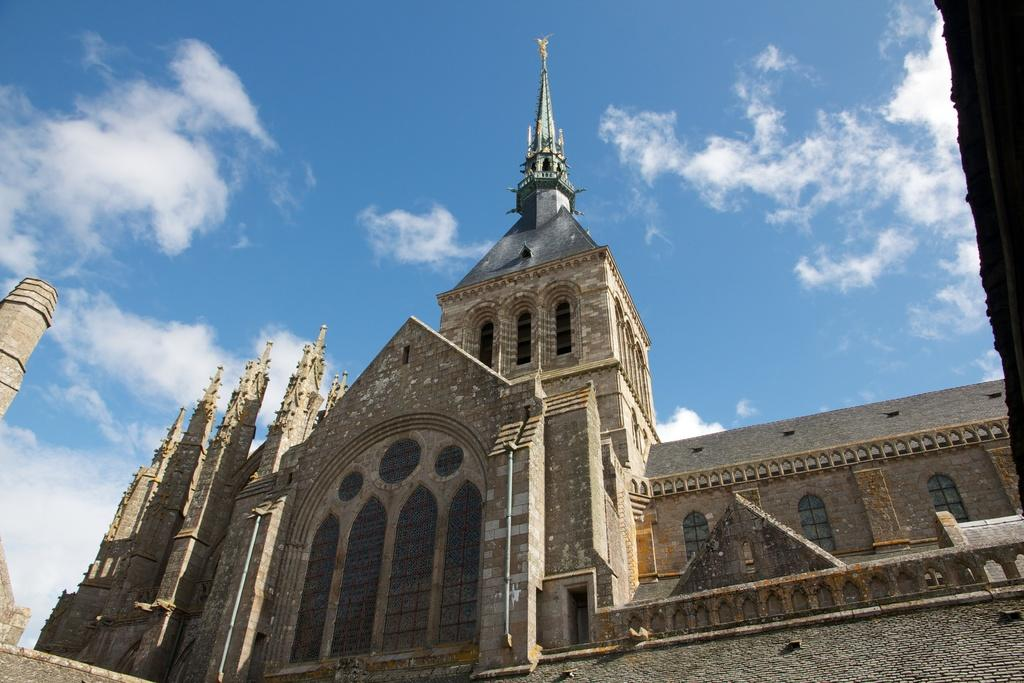What type of structure is present in the image? There is a building in the image. Can you describe the appearance of the building? The building resembles a church. What can be seen in the sky at the top of the image? There are clouds visible in the sky. What is the profit margin of the church in the image? There is no information about the profit margin of the church in the image, as it is not relevant to the visual content. 